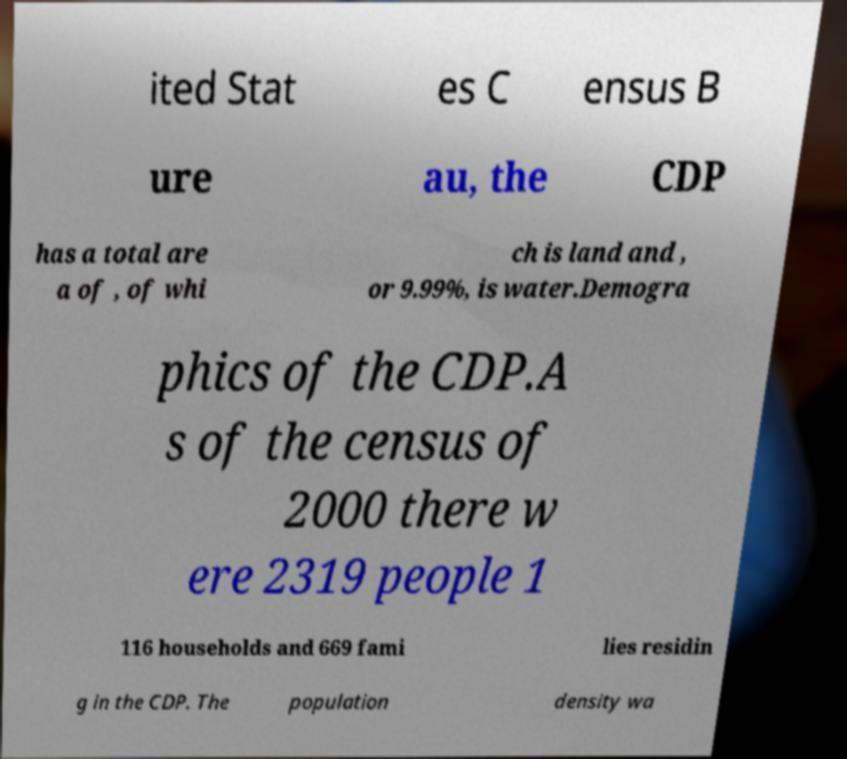Please identify and transcribe the text found in this image. ited Stat es C ensus B ure au, the CDP has a total are a of , of whi ch is land and , or 9.99%, is water.Demogra phics of the CDP.A s of the census of 2000 there w ere 2319 people 1 116 households and 669 fami lies residin g in the CDP. The population density wa 